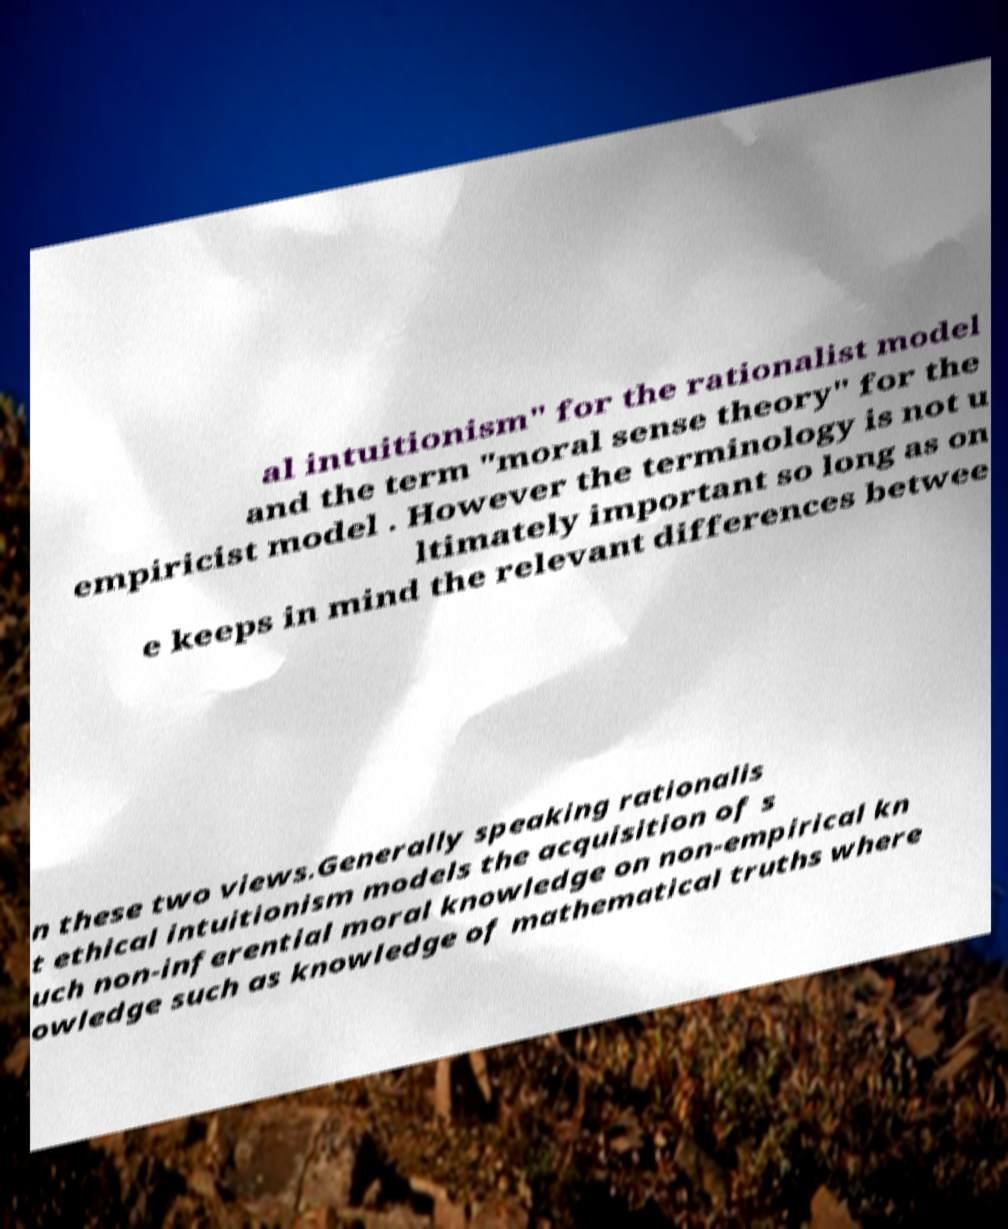Can you accurately transcribe the text from the provided image for me? al intuitionism" for the rationalist model and the term "moral sense theory" for the empiricist model . However the terminology is not u ltimately important so long as on e keeps in mind the relevant differences betwee n these two views.Generally speaking rationalis t ethical intuitionism models the acquisition of s uch non-inferential moral knowledge on non-empirical kn owledge such as knowledge of mathematical truths where 